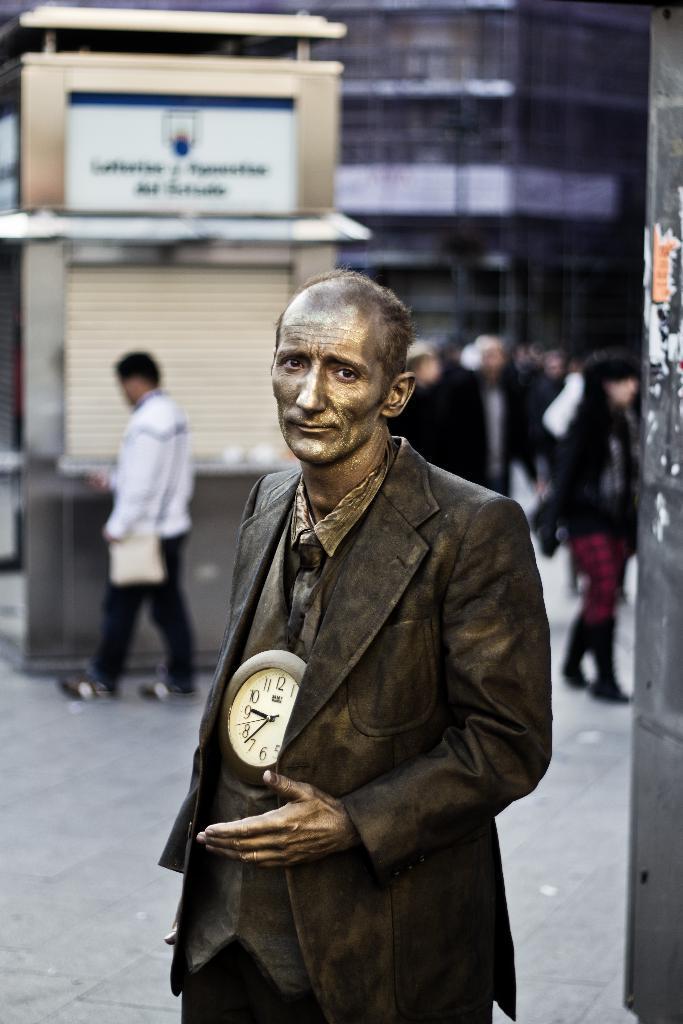In one or two sentences, can you explain what this image depicts? In the front of the image we can see a person. Near that person there is a clock. In the background it is blur. We can see a building, site, hoarding and people. 